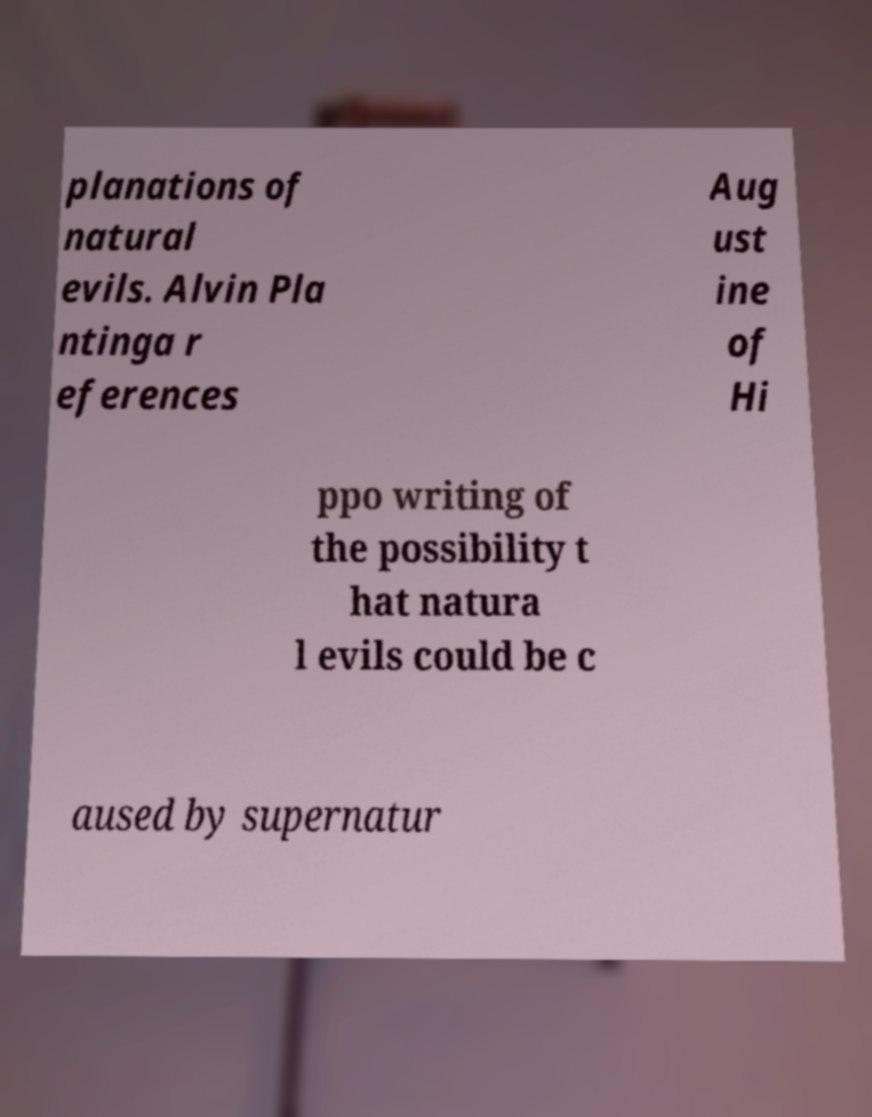For documentation purposes, I need the text within this image transcribed. Could you provide that? planations of natural evils. Alvin Pla ntinga r eferences Aug ust ine of Hi ppo writing of the possibility t hat natura l evils could be c aused by supernatur 